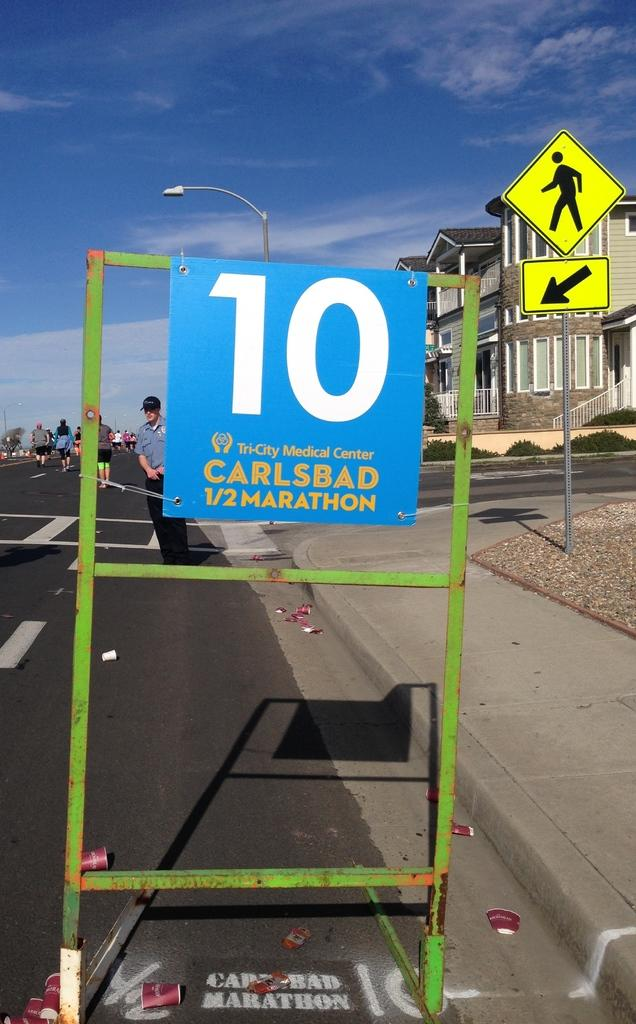<image>
Offer a succinct explanation of the picture presented. A blue sign for the Carlsbad 1/2 marathon sits on the side of the road. 